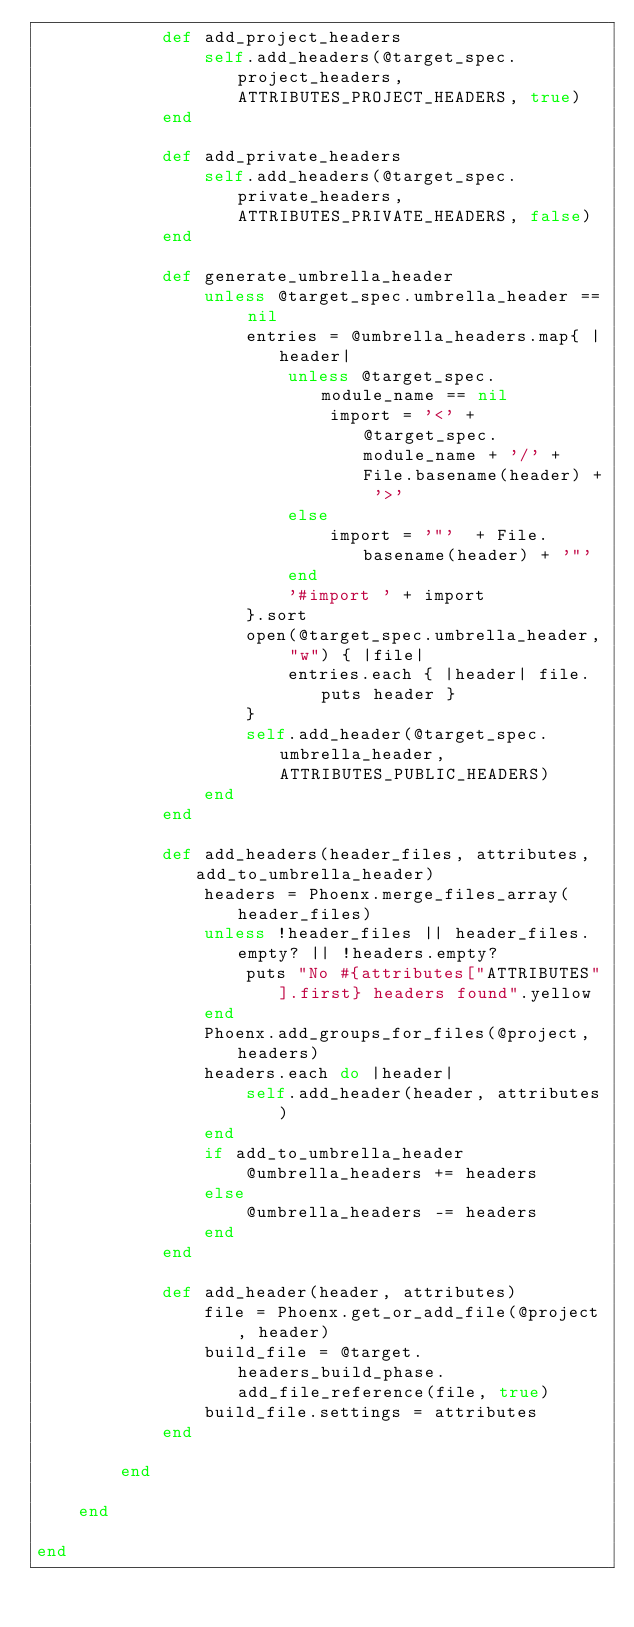Convert code to text. <code><loc_0><loc_0><loc_500><loc_500><_Ruby_>			def add_project_headers
				self.add_headers(@target_spec.project_headers, ATTRIBUTES_PROJECT_HEADERS, true)
			end
			
			def add_private_headers
				self.add_headers(@target_spec.private_headers, ATTRIBUTES_PRIVATE_HEADERS, false)
			end
			
			def generate_umbrella_header
				unless @target_spec.umbrella_header == nil
					entries = @umbrella_headers.map{ |header| 
						unless @target_spec.module_name == nil
							import = '<' + @target_spec.module_name + '/' + File.basename(header) + '>'
						else
							import = '"'  + File.basename(header) + '"'
						end
						'#import ' + import
					}.sort
					open(@target_spec.umbrella_header, "w") { |file| 
						entries.each { |header| file.puts header }
					}
					self.add_header(@target_spec.umbrella_header, ATTRIBUTES_PUBLIC_HEADERS)
				end
			end

			def add_headers(header_files, attributes, add_to_umbrella_header)
				headers = Phoenx.merge_files_array(header_files)
				unless !header_files || header_files.empty? || !headers.empty?
					puts "No #{attributes["ATTRIBUTES"].first} headers found".yellow
				end
				Phoenx.add_groups_for_files(@project, headers)
				headers.each do |header|
					self.add_header(header, attributes)
				end
				if add_to_umbrella_header
					@umbrella_headers += headers
				else 
					@umbrella_headers -= headers
				end
			end

			def add_header(header, attributes)
				file = Phoenx.get_or_add_file(@project, header)
				build_file = @target.headers_build_phase.add_file_reference(file, true)
				build_file.settings = attributes
			end

		end

	end

end
</code> 